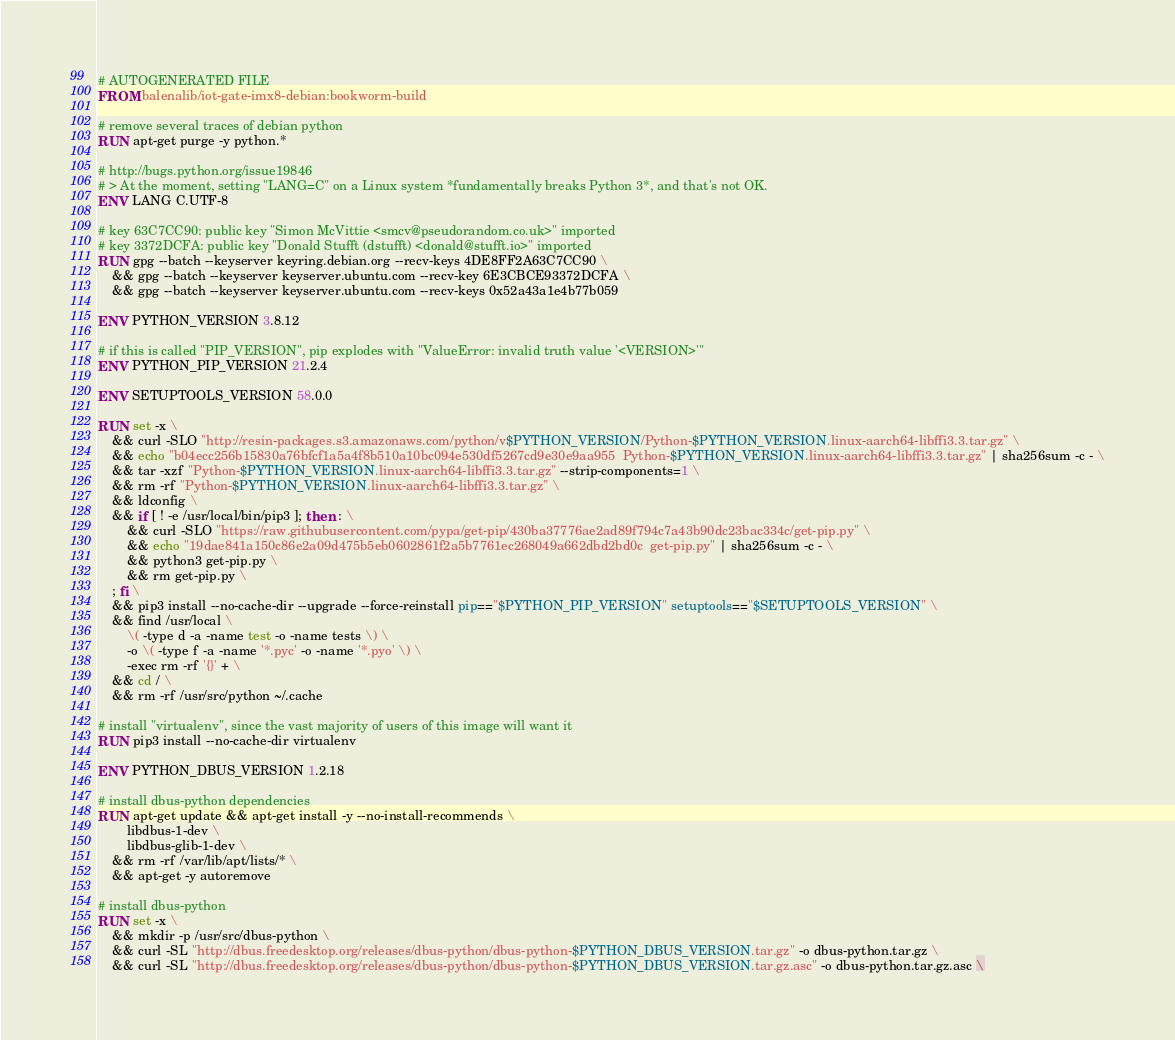Convert code to text. <code><loc_0><loc_0><loc_500><loc_500><_Dockerfile_># AUTOGENERATED FILE
FROM balenalib/iot-gate-imx8-debian:bookworm-build

# remove several traces of debian python
RUN apt-get purge -y python.*

# http://bugs.python.org/issue19846
# > At the moment, setting "LANG=C" on a Linux system *fundamentally breaks Python 3*, and that's not OK.
ENV LANG C.UTF-8

# key 63C7CC90: public key "Simon McVittie <smcv@pseudorandom.co.uk>" imported
# key 3372DCFA: public key "Donald Stufft (dstufft) <donald@stufft.io>" imported
RUN gpg --batch --keyserver keyring.debian.org --recv-keys 4DE8FF2A63C7CC90 \
	&& gpg --batch --keyserver keyserver.ubuntu.com --recv-key 6E3CBCE93372DCFA \
	&& gpg --batch --keyserver keyserver.ubuntu.com --recv-keys 0x52a43a1e4b77b059

ENV PYTHON_VERSION 3.8.12

# if this is called "PIP_VERSION", pip explodes with "ValueError: invalid truth value '<VERSION>'"
ENV PYTHON_PIP_VERSION 21.2.4

ENV SETUPTOOLS_VERSION 58.0.0

RUN set -x \
	&& curl -SLO "http://resin-packages.s3.amazonaws.com/python/v$PYTHON_VERSION/Python-$PYTHON_VERSION.linux-aarch64-libffi3.3.tar.gz" \
	&& echo "b04ecc256b15830a76bfcf1a5a4f8b510a10bc094e530df5267cd9e30e9aa955  Python-$PYTHON_VERSION.linux-aarch64-libffi3.3.tar.gz" | sha256sum -c - \
	&& tar -xzf "Python-$PYTHON_VERSION.linux-aarch64-libffi3.3.tar.gz" --strip-components=1 \
	&& rm -rf "Python-$PYTHON_VERSION.linux-aarch64-libffi3.3.tar.gz" \
	&& ldconfig \
	&& if [ ! -e /usr/local/bin/pip3 ]; then : \
		&& curl -SLO "https://raw.githubusercontent.com/pypa/get-pip/430ba37776ae2ad89f794c7a43b90dc23bac334c/get-pip.py" \
		&& echo "19dae841a150c86e2a09d475b5eb0602861f2a5b7761ec268049a662dbd2bd0c  get-pip.py" | sha256sum -c - \
		&& python3 get-pip.py \
		&& rm get-pip.py \
	; fi \
	&& pip3 install --no-cache-dir --upgrade --force-reinstall pip=="$PYTHON_PIP_VERSION" setuptools=="$SETUPTOOLS_VERSION" \
	&& find /usr/local \
		\( -type d -a -name test -o -name tests \) \
		-o \( -type f -a -name '*.pyc' -o -name '*.pyo' \) \
		-exec rm -rf '{}' + \
	&& cd / \
	&& rm -rf /usr/src/python ~/.cache

# install "virtualenv", since the vast majority of users of this image will want it
RUN pip3 install --no-cache-dir virtualenv

ENV PYTHON_DBUS_VERSION 1.2.18

# install dbus-python dependencies 
RUN apt-get update && apt-get install -y --no-install-recommends \
		libdbus-1-dev \
		libdbus-glib-1-dev \
	&& rm -rf /var/lib/apt/lists/* \
	&& apt-get -y autoremove

# install dbus-python
RUN set -x \
	&& mkdir -p /usr/src/dbus-python \
	&& curl -SL "http://dbus.freedesktop.org/releases/dbus-python/dbus-python-$PYTHON_DBUS_VERSION.tar.gz" -o dbus-python.tar.gz \
	&& curl -SL "http://dbus.freedesktop.org/releases/dbus-python/dbus-python-$PYTHON_DBUS_VERSION.tar.gz.asc" -o dbus-python.tar.gz.asc \</code> 